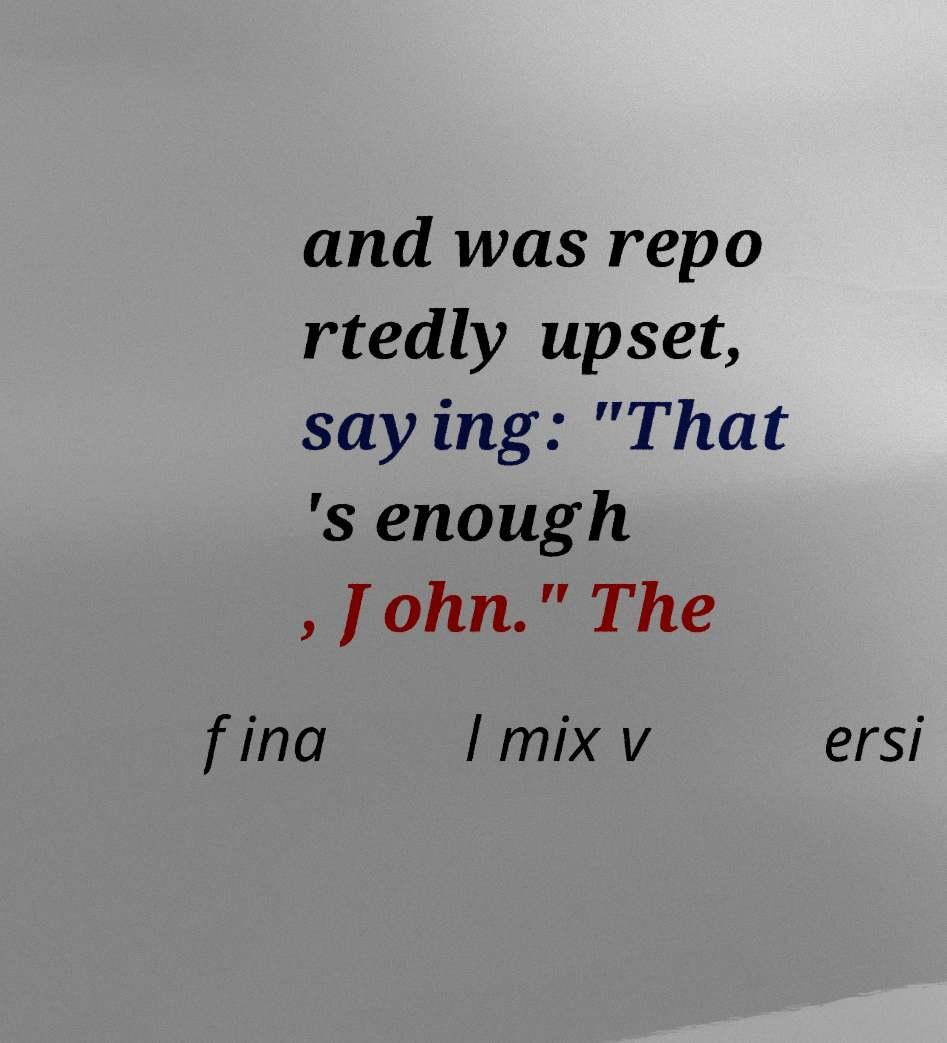Could you assist in decoding the text presented in this image and type it out clearly? and was repo rtedly upset, saying: "That 's enough , John." The fina l mix v ersi 